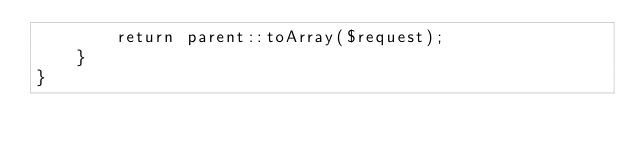Convert code to text. <code><loc_0><loc_0><loc_500><loc_500><_PHP_>        return parent::toArray($request);
    }
}
</code> 